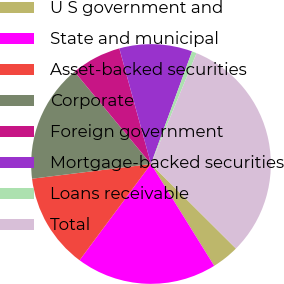Convert chart. <chart><loc_0><loc_0><loc_500><loc_500><pie_chart><fcel>U S government and<fcel>State and municipal<fcel>Asset-backed securities<fcel>Corporate<fcel>Foreign government<fcel>Mortgage-backed securities<fcel>Loans receivable<fcel>Total<nl><fcel>3.7%<fcel>19.0%<fcel>12.88%<fcel>15.94%<fcel>6.76%<fcel>9.82%<fcel>0.64%<fcel>31.25%<nl></chart> 